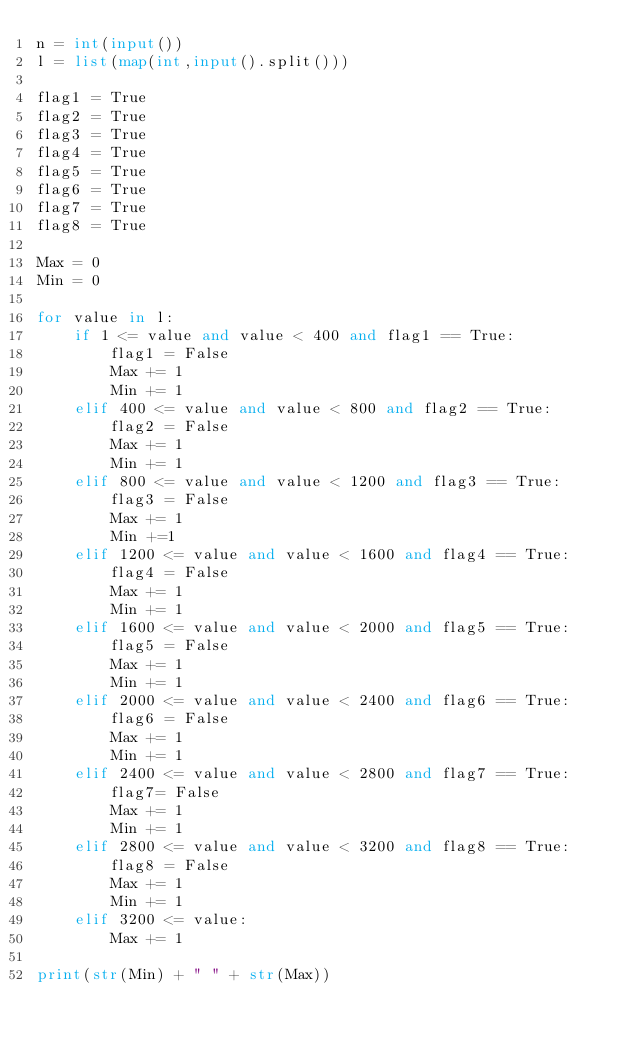Convert code to text. <code><loc_0><loc_0><loc_500><loc_500><_Python_>n = int(input())
l = list(map(int,input().split()))

flag1 = True
flag2 = True
flag3 = True
flag4 = True
flag5 = True
flag6 = True
flag7 = True
flag8 = True

Max = 0
Min = 0

for value in l:
	if 1 <= value and value < 400 and flag1 == True:
		flag1 = False
		Max += 1
		Min += 1
	elif 400 <= value and value < 800 and flag2 == True:
		flag2 = False
		Max += 1
		Min += 1
	elif 800 <= value and value < 1200 and flag3 == True:
		flag3 = False
		Max += 1
		Min +=1
	elif 1200 <= value and value < 1600 and flag4 == True:
		flag4 = False
		Max += 1
		Min += 1
	elif 1600 <= value and value < 2000 and flag5 == True:
		flag5 = False
		Max += 1
		Min += 1
	elif 2000 <= value and value < 2400 and flag6 == True:
		flag6 = False
		Max += 1
		Min += 1
	elif 2400 <= value and value < 2800 and flag7 == True:
		flag7= False
		Max += 1
		Min += 1
	elif 2800 <= value and value < 3200 and flag8 == True:
		flag8 = False
		Max += 1
		Min += 1
	elif 3200 <= value:
		Max += 1

print(str(Min) + " " + str(Max))
</code> 